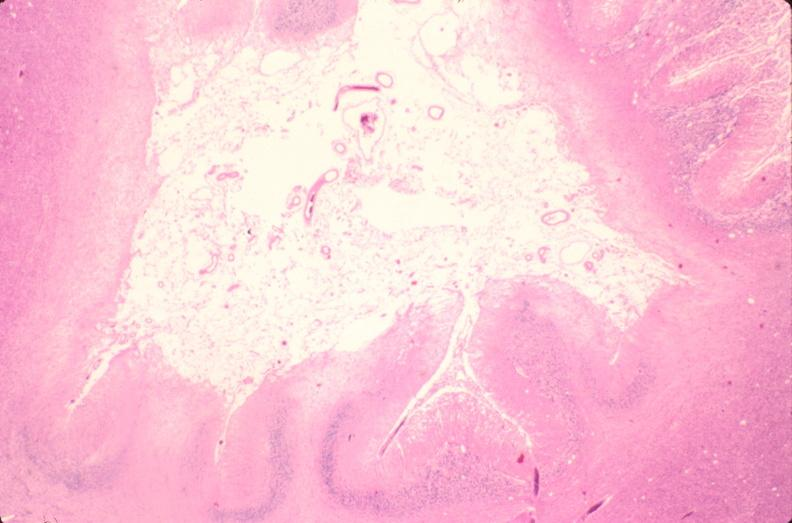s ap view present?
Answer the question using a single word or phrase. No 